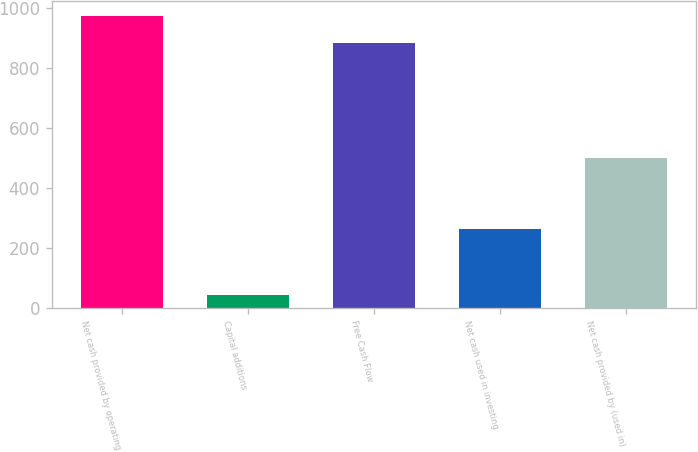<chart> <loc_0><loc_0><loc_500><loc_500><bar_chart><fcel>Net cash provided by operating<fcel>Capital additions<fcel>Free Cash Flow<fcel>Net cash used in investing<fcel>Net cash provided by (used in)<nl><fcel>972.95<fcel>42.3<fcel>884.5<fcel>261.9<fcel>498.8<nl></chart> 